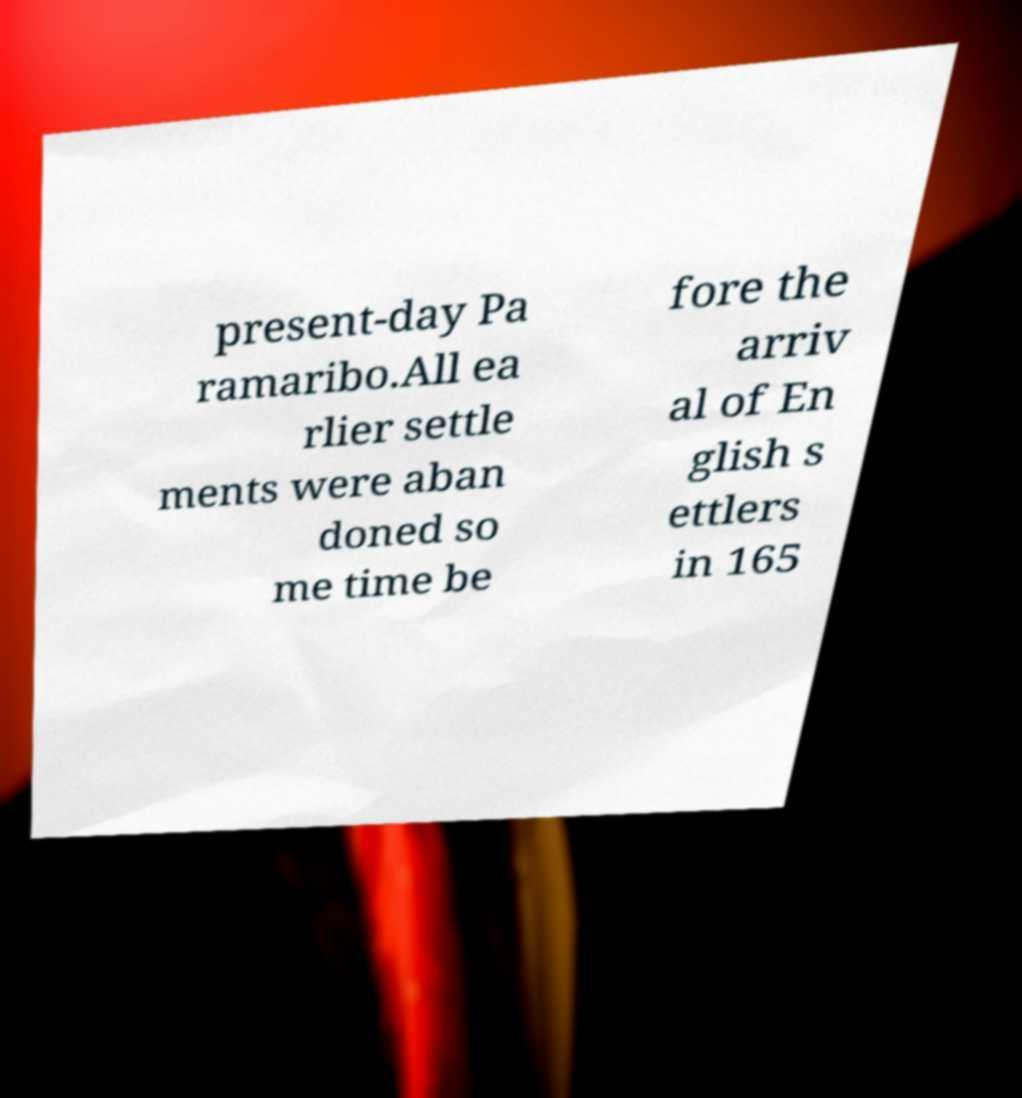There's text embedded in this image that I need extracted. Can you transcribe it verbatim? present-day Pa ramaribo.All ea rlier settle ments were aban doned so me time be fore the arriv al of En glish s ettlers in 165 